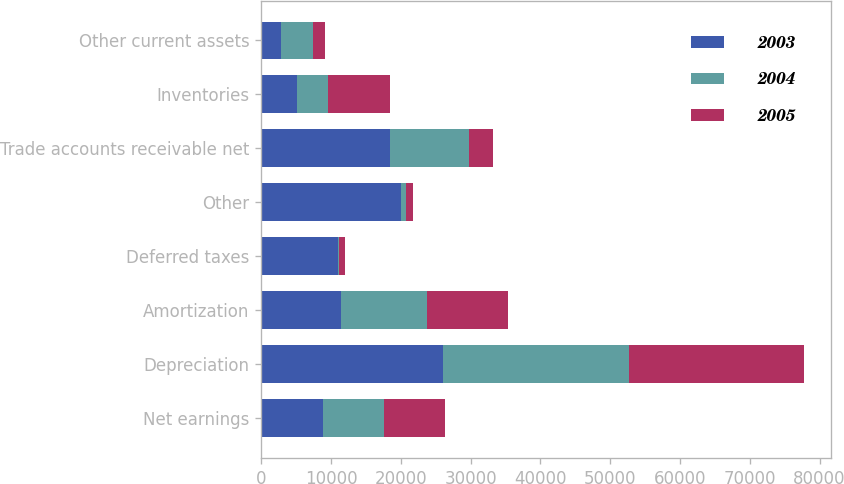Convert chart. <chart><loc_0><loc_0><loc_500><loc_500><stacked_bar_chart><ecel><fcel>Net earnings<fcel>Depreciation<fcel>Amortization<fcel>Deferred taxes<fcel>Other<fcel>Trade accounts receivable net<fcel>Inventories<fcel>Other current assets<nl><fcel>2003<fcel>8773<fcel>25977<fcel>11436<fcel>10962<fcel>20057<fcel>18377<fcel>5171<fcel>2790<nl><fcel>2004<fcel>8773<fcel>26668<fcel>12256<fcel>107<fcel>676<fcel>11337<fcel>4449<fcel>4584<nl><fcel>2005<fcel>8773<fcel>25086<fcel>11724<fcel>953<fcel>940<fcel>3516<fcel>8773<fcel>1708<nl></chart> 